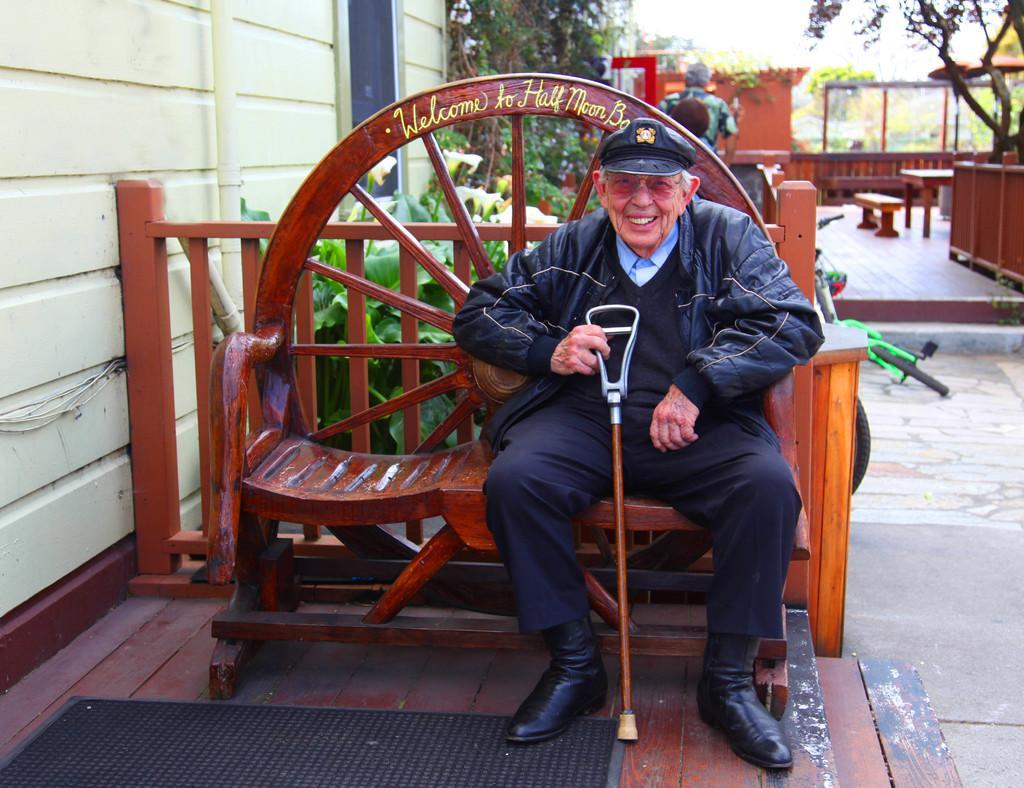Can you describe this image briefly? Here we can see a old man with a stick in his hand wearing a cap sitting on a bench and behind him we can see plants and trees present 